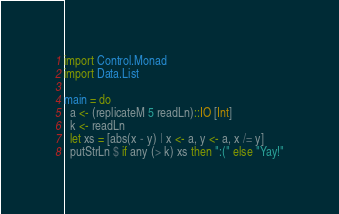<code> <loc_0><loc_0><loc_500><loc_500><_Haskell_>import Control.Monad
import Data.List

main = do
  a <- (replicateM 5 readLn)::IO [Int]
  k <- readLn
  let xs = [abs(x - y) | x <- a, y <- a, x /= y]
  putStrLn $ if any (> k) xs then ":(" else "Yay!"</code> 